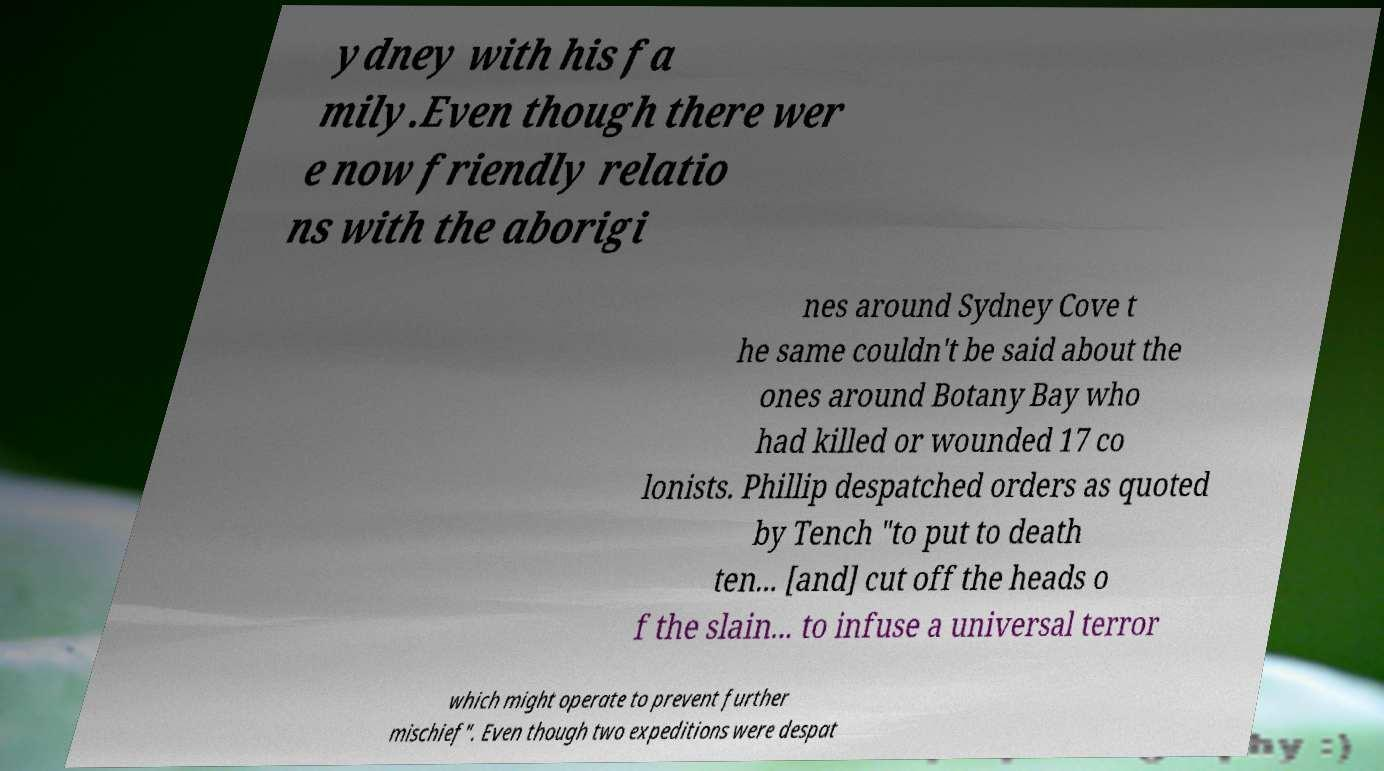Could you extract and type out the text from this image? ydney with his fa mily.Even though there wer e now friendly relatio ns with the aborigi nes around Sydney Cove t he same couldn't be said about the ones around Botany Bay who had killed or wounded 17 co lonists. Phillip despatched orders as quoted by Tench "to put to death ten... [and] cut off the heads o f the slain... to infuse a universal terror which might operate to prevent further mischief". Even though two expeditions were despat 